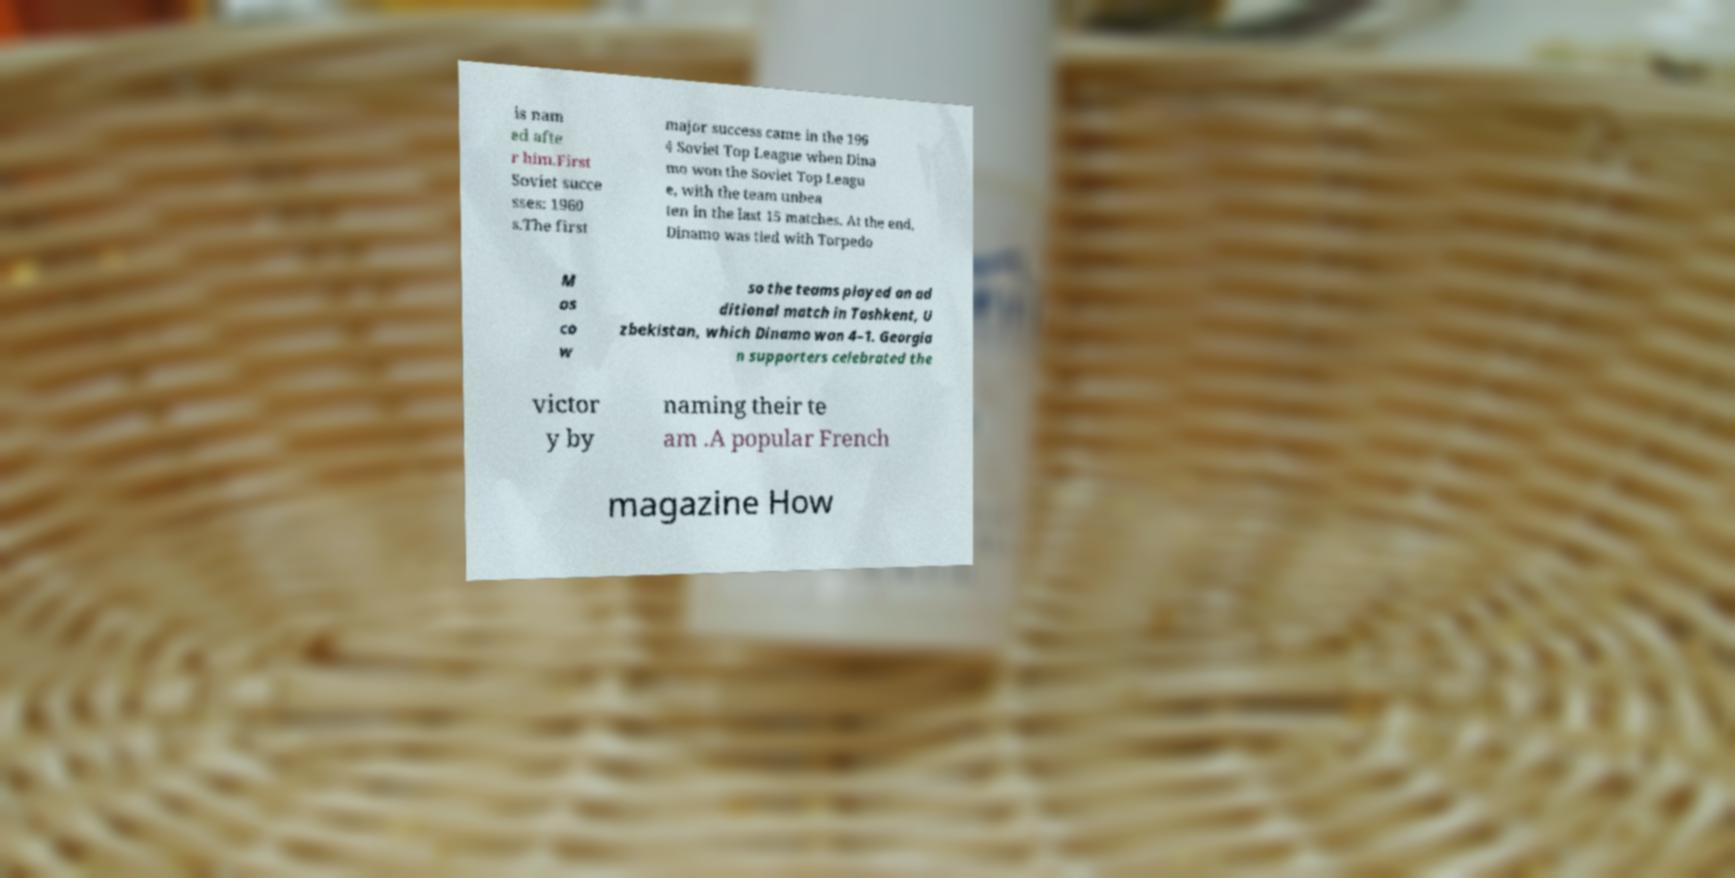Could you extract and type out the text from this image? is nam ed afte r him.First Soviet succe sses: 1960 s.The first major success came in the 196 4 Soviet Top League when Dina mo won the Soviet Top Leagu e, with the team unbea ten in the last 15 matches. At the end, Dinamo was tied with Torpedo M os co w so the teams played an ad ditional match in Tashkent, U zbekistan, which Dinamo won 4–1. Georgia n supporters celebrated the victor y by naming their te am .A popular French magazine How 